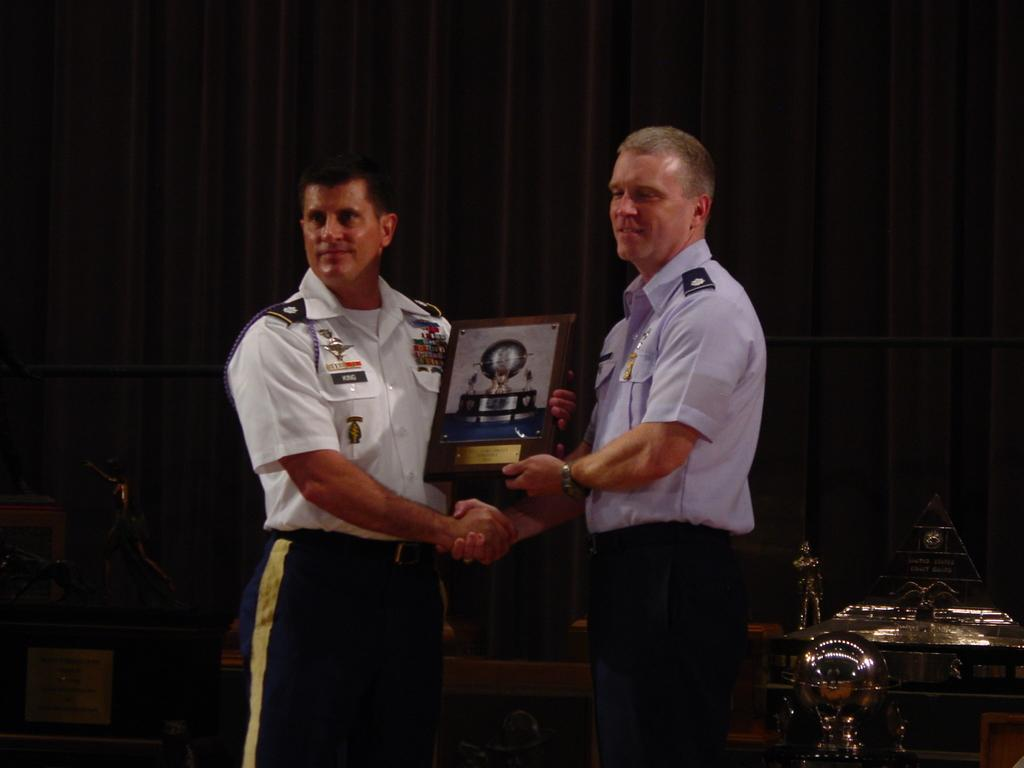How many people are in the image? There are two men in the image. What are the men doing in the image? The men are standing and holding a frame in their hands. What can be seen in the background of the image? There are black curtains in the background of the image. What type of furniture is expanding in the image? There is no furniture present in the image, and therefore no expansion can be observed. 